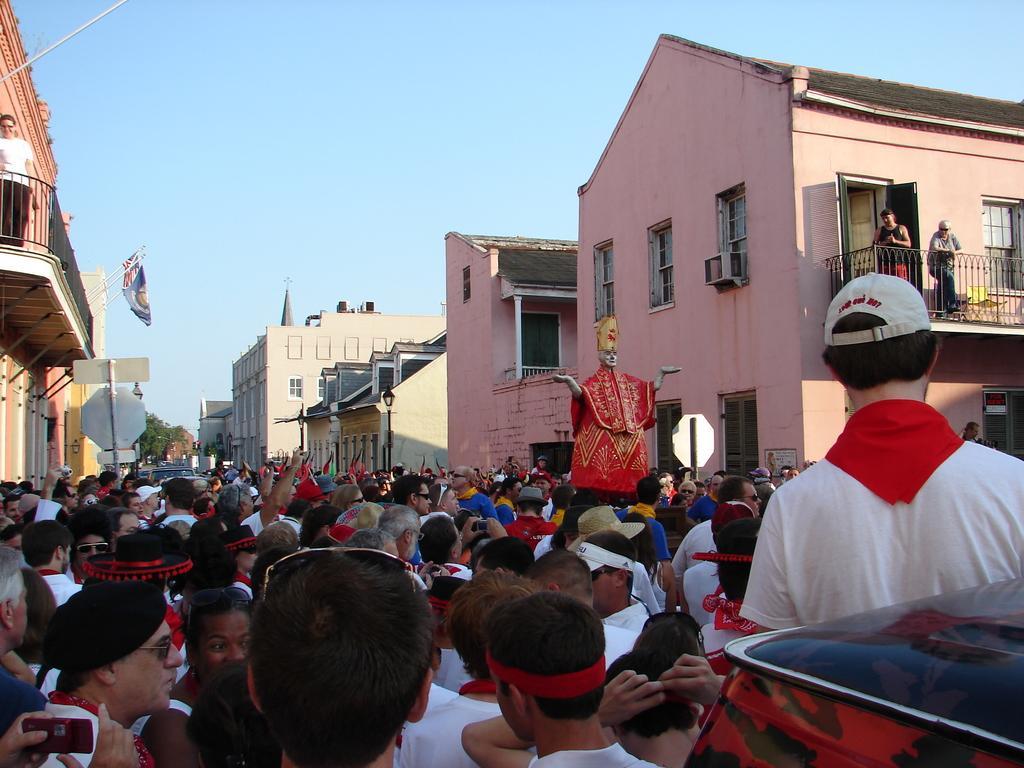Can you describe this image briefly? In this image I can see number of persons standing. To the right bottom of the image I can see an object which is black and red in color. In the background I can see few buildings, few flags, few persons standing on the buildings, few trees and the sky. 